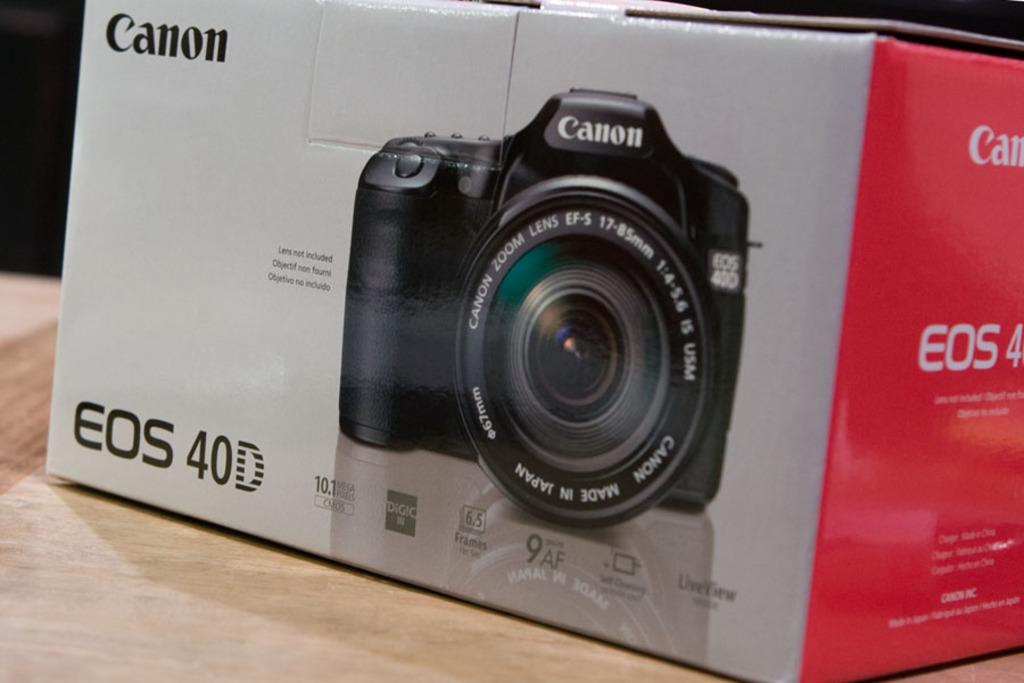What is the main object in the image? There is a box in the image. Where is the box located? on the image? What is depicted on the box? There is an image of a camera on the box. What information can be found on the box? There is text written on the box. Can you see a tramp performing in the background of the image? There is no tramp performing in the background of the image. Is there a stranger interacting with the box in the image? There is no stranger interacting with the box in the image. 